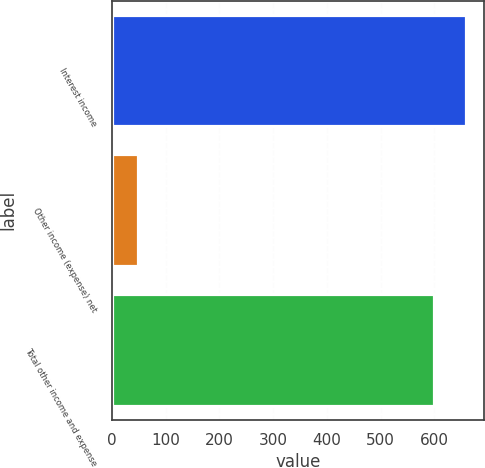<chart> <loc_0><loc_0><loc_500><loc_500><bar_chart><fcel>Interest income<fcel>Other income (expense) net<fcel>Total other income and expense<nl><fcel>658.9<fcel>48<fcel>599<nl></chart> 